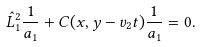<formula> <loc_0><loc_0><loc_500><loc_500>\hat { L } _ { 1 } ^ { 2 } \frac { 1 } { a _ { 1 } } + C ( x , y - v _ { 2 } t ) \frac { 1 } { a _ { 1 } } = 0 .</formula> 